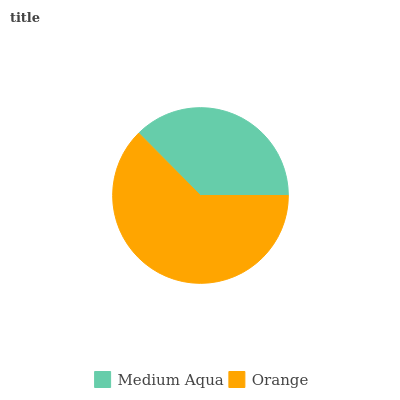Is Medium Aqua the minimum?
Answer yes or no. Yes. Is Orange the maximum?
Answer yes or no. Yes. Is Orange the minimum?
Answer yes or no. No. Is Orange greater than Medium Aqua?
Answer yes or no. Yes. Is Medium Aqua less than Orange?
Answer yes or no. Yes. Is Medium Aqua greater than Orange?
Answer yes or no. No. Is Orange less than Medium Aqua?
Answer yes or no. No. Is Orange the high median?
Answer yes or no. Yes. Is Medium Aqua the low median?
Answer yes or no. Yes. Is Medium Aqua the high median?
Answer yes or no. No. Is Orange the low median?
Answer yes or no. No. 